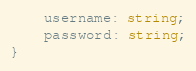<code> <loc_0><loc_0><loc_500><loc_500><_TypeScript_>    username: string;
    password: string;
}
</code> 